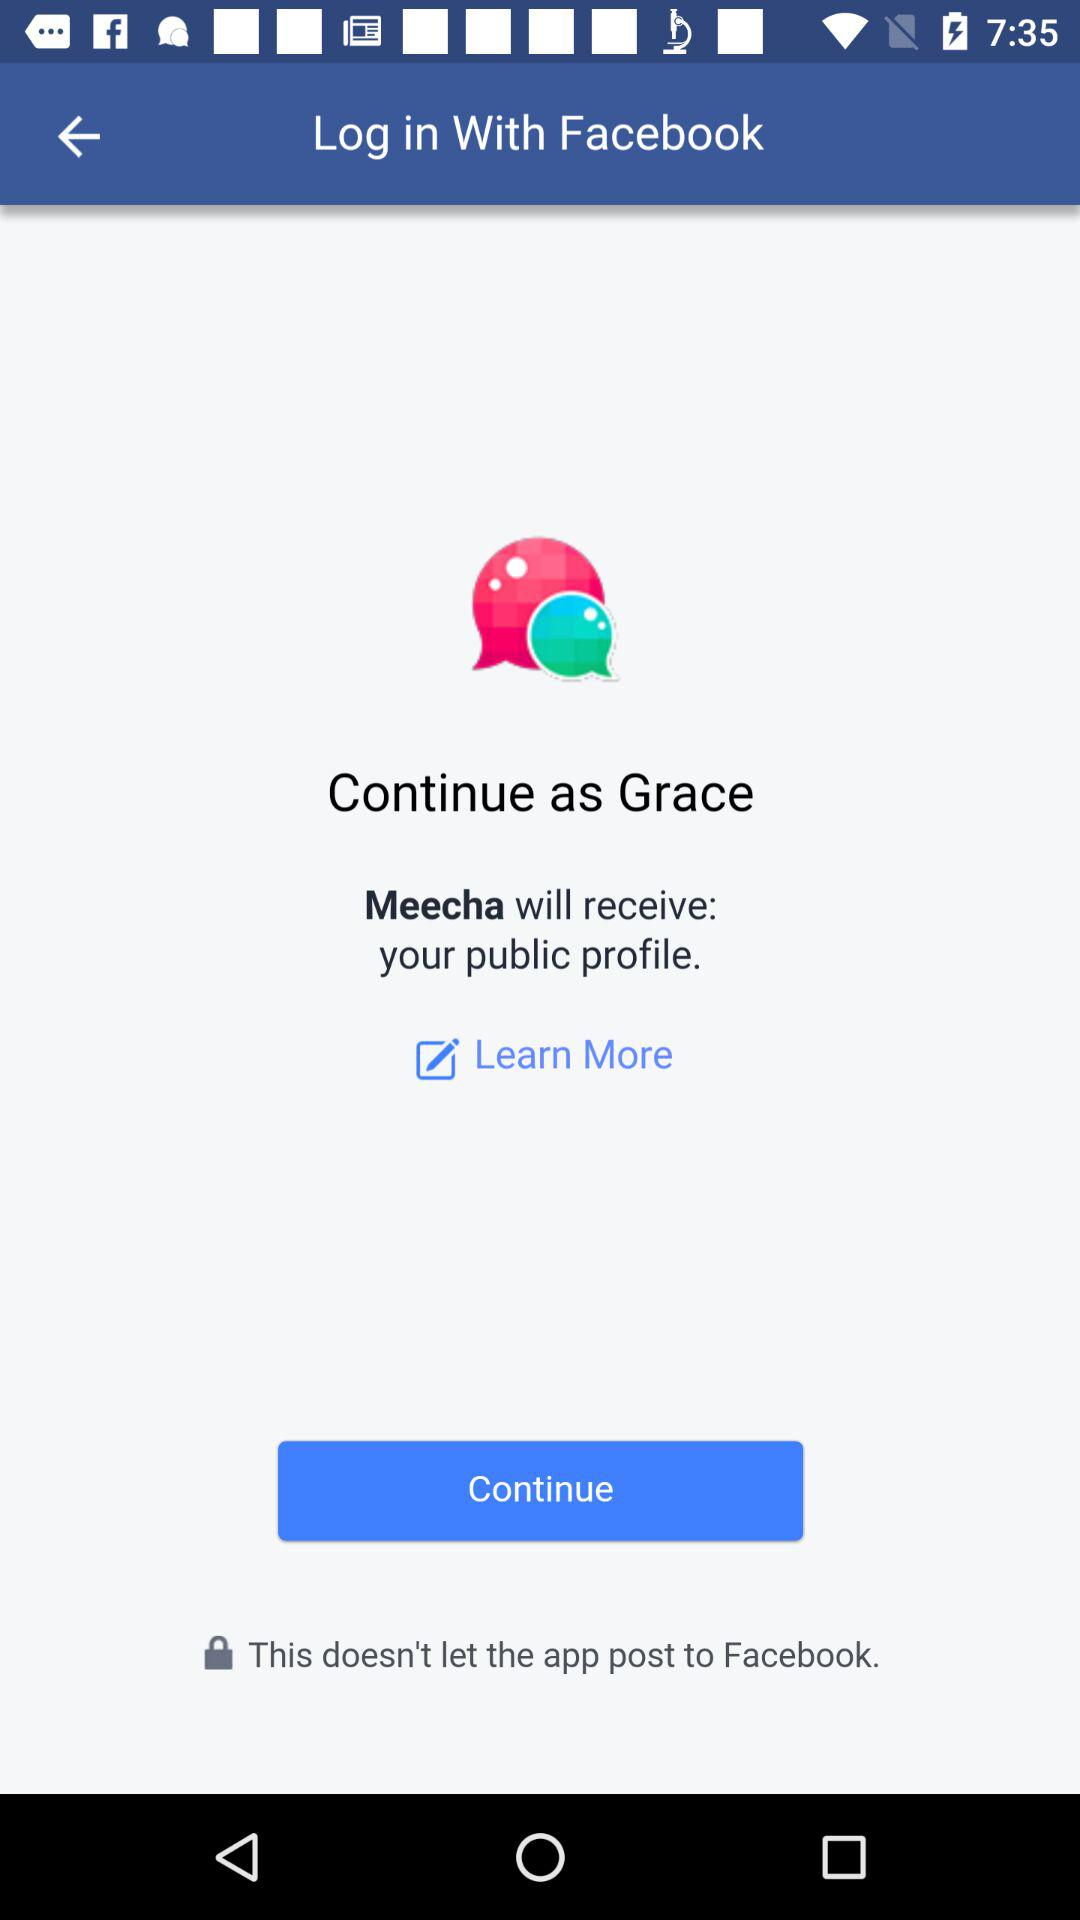Through what application is the person logging in? The person is logging in through "Facebook". 